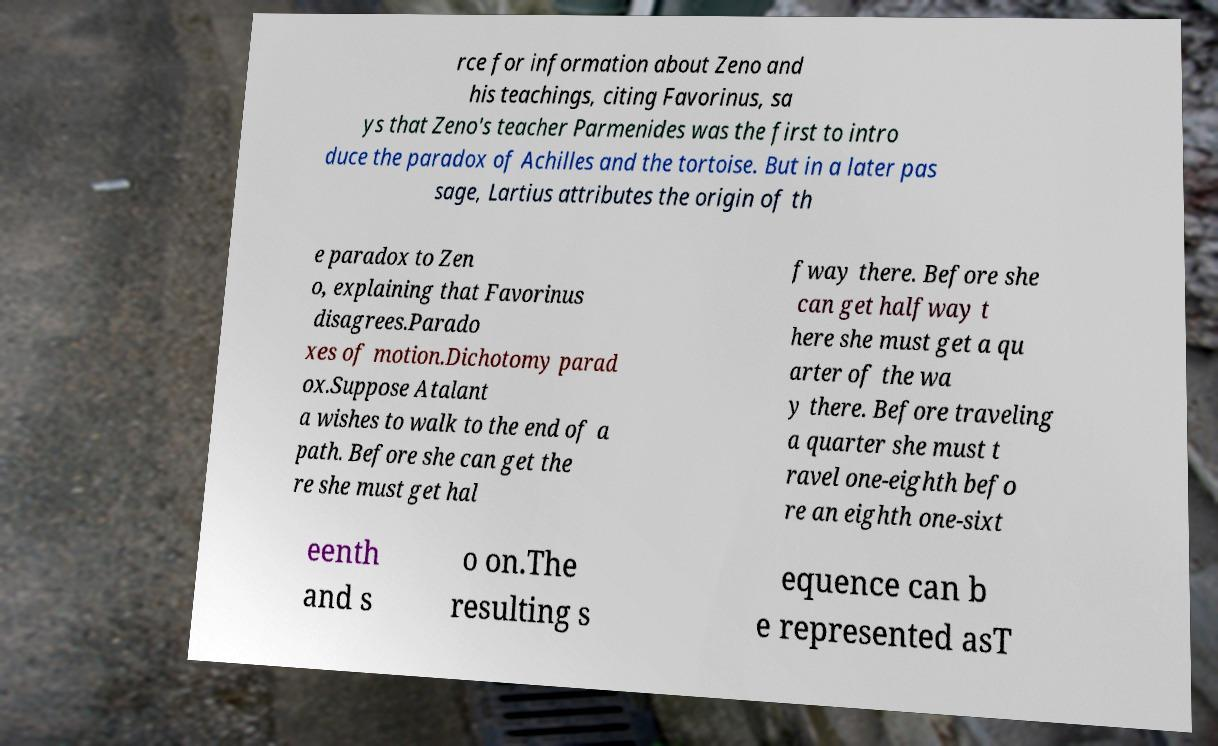For documentation purposes, I need the text within this image transcribed. Could you provide that? rce for information about Zeno and his teachings, citing Favorinus, sa ys that Zeno's teacher Parmenides was the first to intro duce the paradox of Achilles and the tortoise. But in a later pas sage, Lartius attributes the origin of th e paradox to Zen o, explaining that Favorinus disagrees.Parado xes of motion.Dichotomy parad ox.Suppose Atalant a wishes to walk to the end of a path. Before she can get the re she must get hal fway there. Before she can get halfway t here she must get a qu arter of the wa y there. Before traveling a quarter she must t ravel one-eighth befo re an eighth one-sixt eenth and s o on.The resulting s equence can b e represented asT 